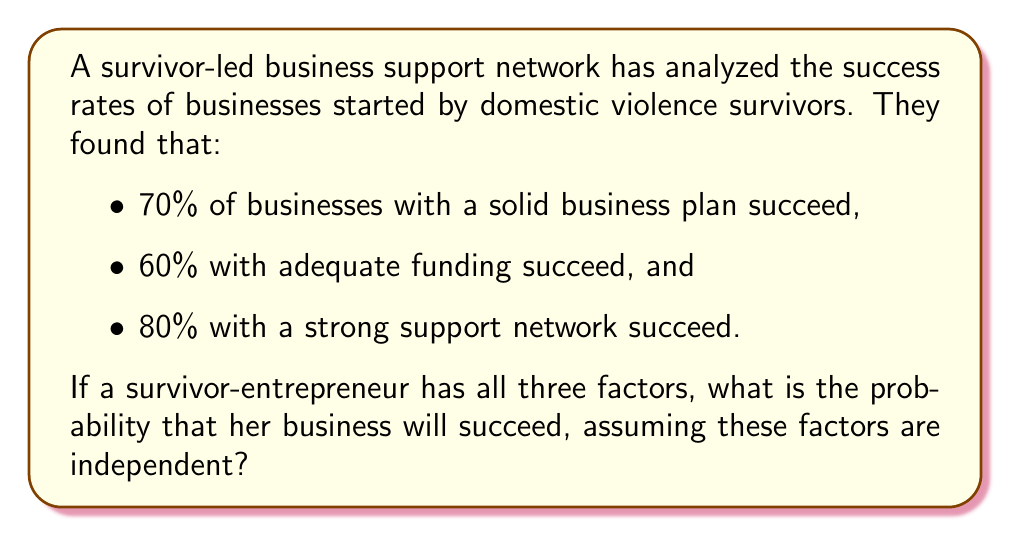Give your solution to this math problem. Let's approach this step-by-step:

1) Let's define our events:
   A: The business has a solid business plan
   B: The business has adequate funding
   C: The business has a strong support network

2) We're given the following probabilities:
   P(success|A) = 0.70
   P(success|B) = 0.60
   P(success|C) = 0.80

3) We need to find the probability of success given all three factors:
   P(success|A ∩ B ∩ C)

4) Assuming independence, we can use the multiplication rule:
   P(success|A ∩ B ∩ C) = P(success|A) × P(success|B) × P(success|C)

5) Substituting the values:
   P(success|A ∩ B ∩ C) = 0.70 × 0.60 × 0.80

6) Calculating:
   P(success|A ∩ B ∩ C) = 0.336

7) Converting to a percentage:
   0.336 × 100% = 33.6%

Therefore, the probability of success for a business with all three factors is 33.6%.
Answer: 33.6% 